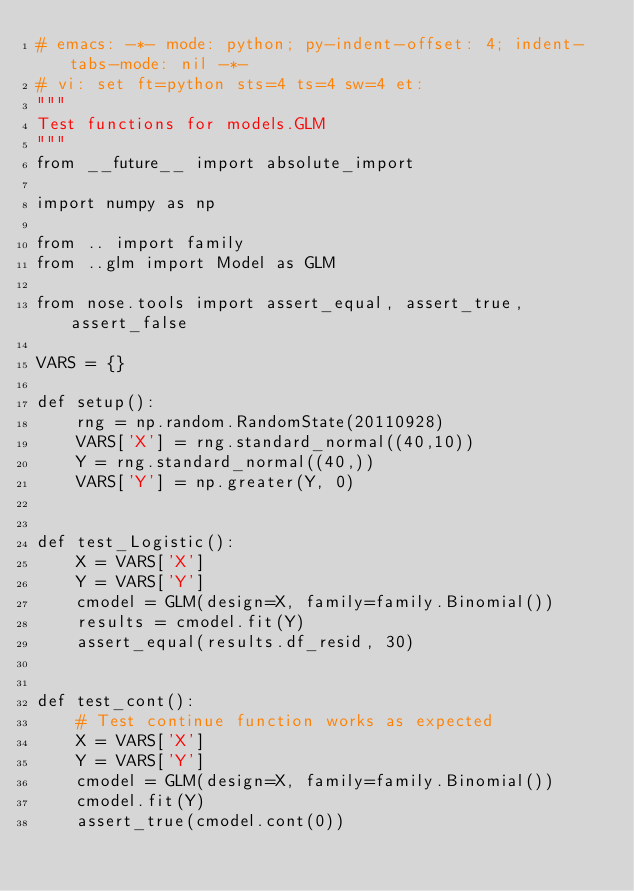Convert code to text. <code><loc_0><loc_0><loc_500><loc_500><_Python_># emacs: -*- mode: python; py-indent-offset: 4; indent-tabs-mode: nil -*-
# vi: set ft=python sts=4 ts=4 sw=4 et:
"""
Test functions for models.GLM
"""
from __future__ import absolute_import

import numpy as np

from .. import family
from ..glm import Model as GLM

from nose.tools import assert_equal, assert_true, assert_false

VARS = {}

def setup():
    rng = np.random.RandomState(20110928)
    VARS['X'] = rng.standard_normal((40,10))
    Y = rng.standard_normal((40,))
    VARS['Y'] = np.greater(Y, 0)


def test_Logistic():
    X = VARS['X']
    Y = VARS['Y']
    cmodel = GLM(design=X, family=family.Binomial())
    results = cmodel.fit(Y)
    assert_equal(results.df_resid, 30)


def test_cont():
    # Test continue function works as expected
    X = VARS['X']
    Y = VARS['Y']
    cmodel = GLM(design=X, family=family.Binomial())
    cmodel.fit(Y)
    assert_true(cmodel.cont(0))</code> 